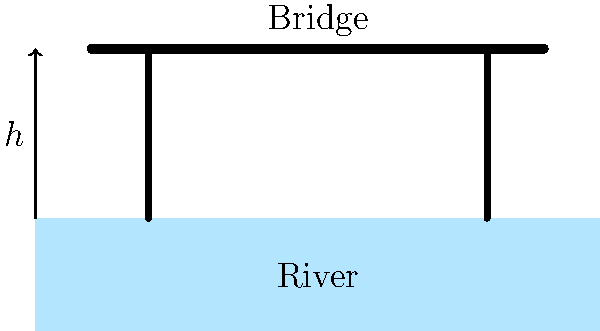Imagine you're building a toy bridge for your parent to cross when they come home. The bridge needs to be high enough for toy boats to pass underneath. If the toy boats are 15 cm tall and we want an extra 5 cm of space above them, how tall should the bridge be from the water level? Let's break this down step by step:

1. We know the toy boats are 15 cm tall.
2. We want an extra 5 cm of space above the boats.
3. To find the total height of the bridge from the water level, we need to add these two numbers together.

So, we can set up our equation:

$$\text{Bridge Height} = \text{Boat Height} + \text{Extra Space}$$

Now, let's plug in our numbers:

$$\text{Bridge Height} = 15 \text{ cm} + 5 \text{ cm}$$

$$\text{Bridge Height} = 20 \text{ cm}$$

Therefore, the bridge should be 20 cm tall from the water level. This way, the toy boats can pass safely underneath, and there's a little extra room just in case!
Answer: 20 cm 